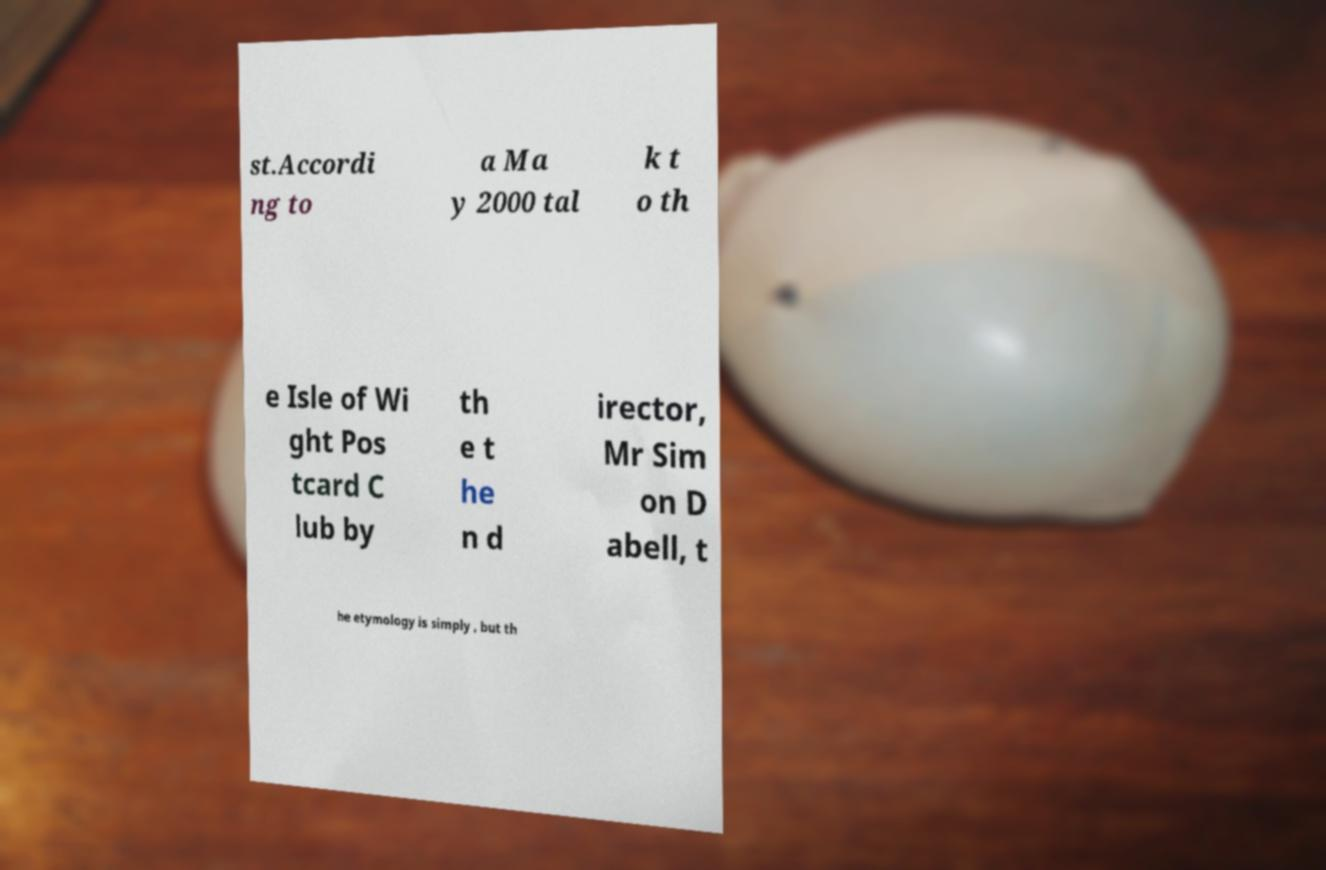I need the written content from this picture converted into text. Can you do that? st.Accordi ng to a Ma y 2000 tal k t o th e Isle of Wi ght Pos tcard C lub by th e t he n d irector, Mr Sim on D abell, t he etymology is simply , but th 